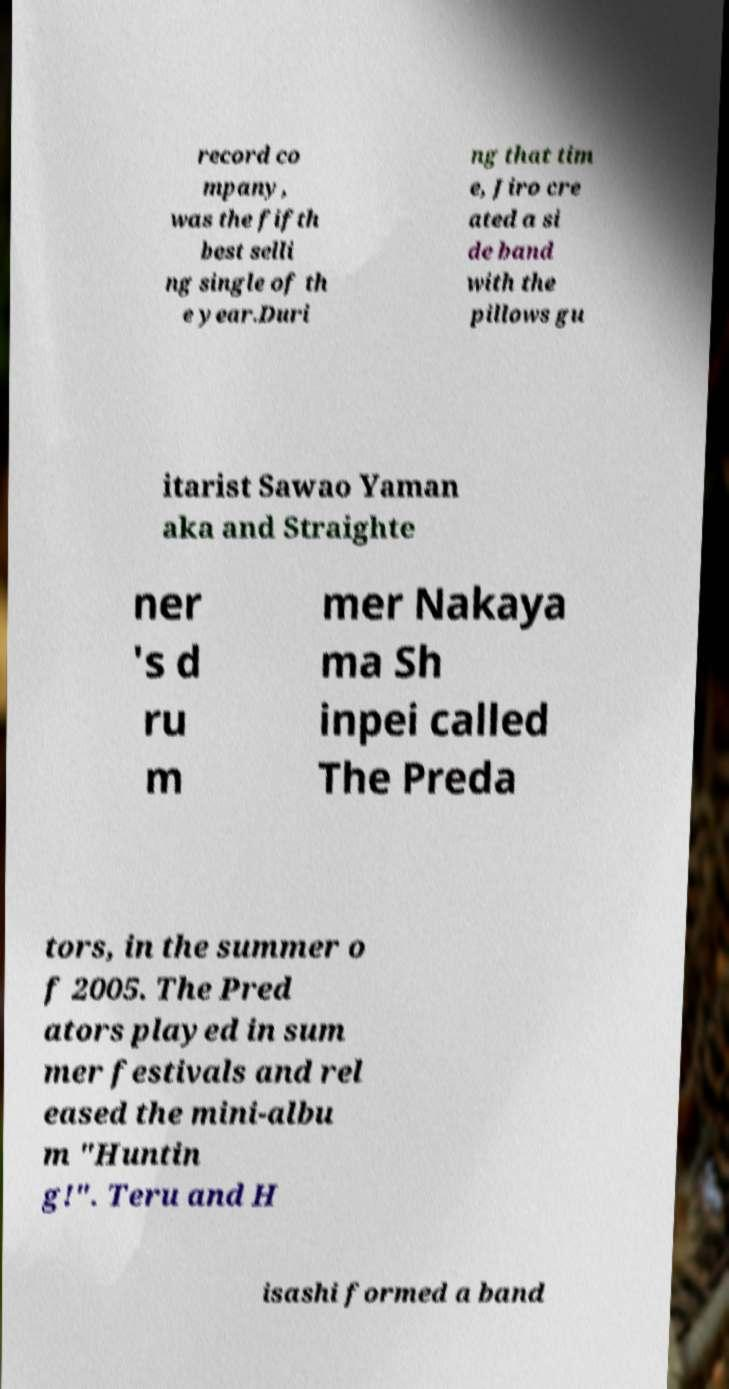Please identify and transcribe the text found in this image. record co mpany, was the fifth best selli ng single of th e year.Duri ng that tim e, Jiro cre ated a si de band with the pillows gu itarist Sawao Yaman aka and Straighte ner 's d ru m mer Nakaya ma Sh inpei called The Preda tors, in the summer o f 2005. The Pred ators played in sum mer festivals and rel eased the mini-albu m "Huntin g!". Teru and H isashi formed a band 